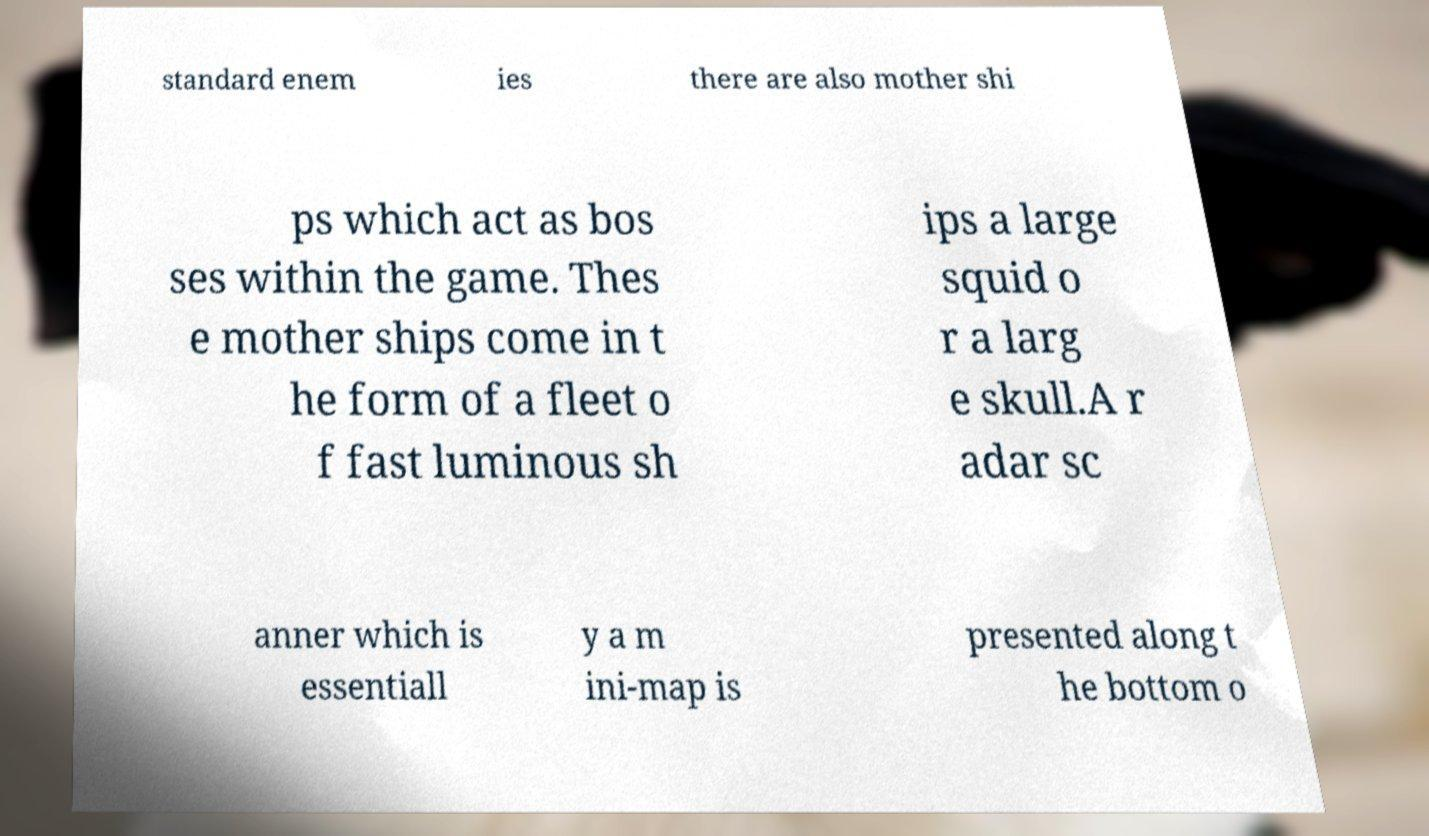Could you assist in decoding the text presented in this image and type it out clearly? standard enem ies there are also mother shi ps which act as bos ses within the game. Thes e mother ships come in t he form of a fleet o f fast luminous sh ips a large squid o r a larg e skull.A r adar sc anner which is essentiall y a m ini-map is presented along t he bottom o 